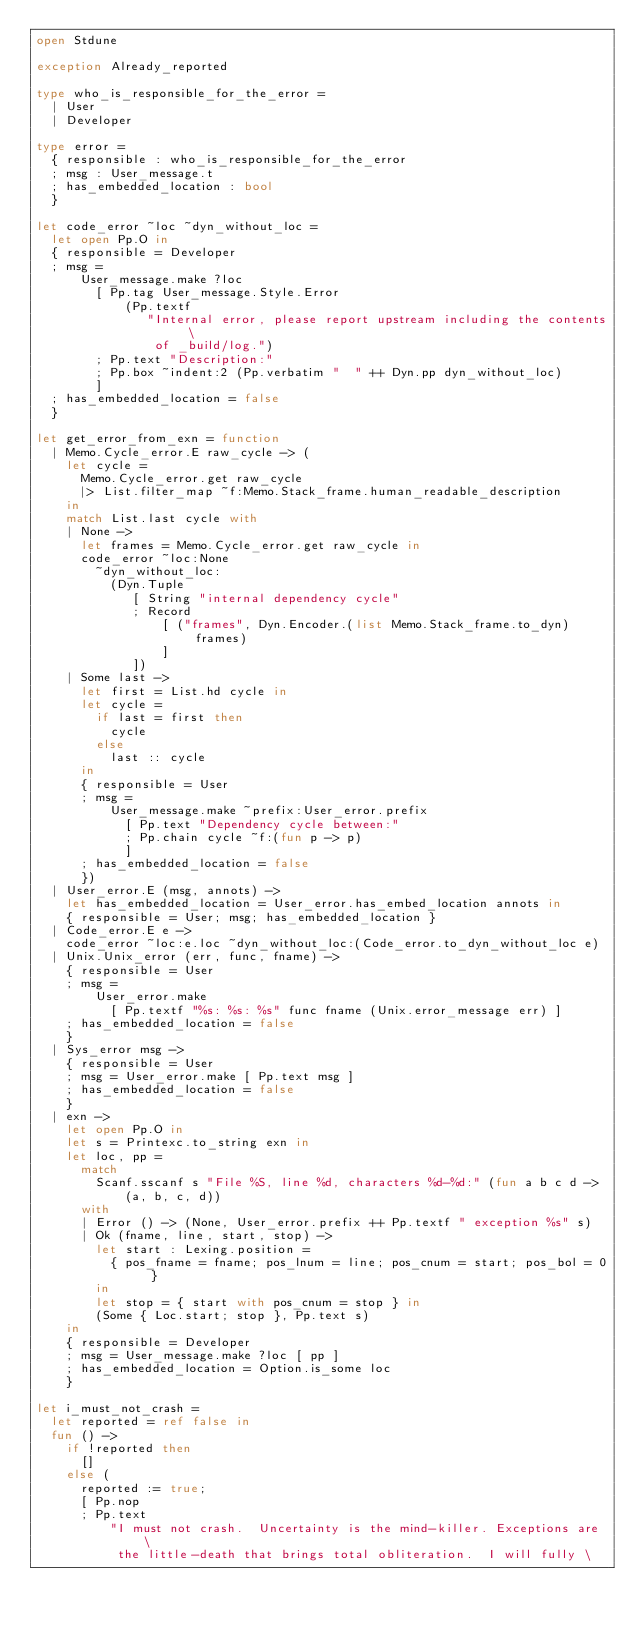<code> <loc_0><loc_0><loc_500><loc_500><_OCaml_>open Stdune

exception Already_reported

type who_is_responsible_for_the_error =
  | User
  | Developer

type error =
  { responsible : who_is_responsible_for_the_error
  ; msg : User_message.t
  ; has_embedded_location : bool
  }

let code_error ~loc ~dyn_without_loc =
  let open Pp.O in
  { responsible = Developer
  ; msg =
      User_message.make ?loc
        [ Pp.tag User_message.Style.Error
            (Pp.textf
               "Internal error, please report upstream including the contents \
                of _build/log.")
        ; Pp.text "Description:"
        ; Pp.box ~indent:2 (Pp.verbatim "  " ++ Dyn.pp dyn_without_loc)
        ]
  ; has_embedded_location = false
  }

let get_error_from_exn = function
  | Memo.Cycle_error.E raw_cycle -> (
    let cycle =
      Memo.Cycle_error.get raw_cycle
      |> List.filter_map ~f:Memo.Stack_frame.human_readable_description
    in
    match List.last cycle with
    | None ->
      let frames = Memo.Cycle_error.get raw_cycle in
      code_error ~loc:None
        ~dyn_without_loc:
          (Dyn.Tuple
             [ String "internal dependency cycle"
             ; Record
                 [ ("frames", Dyn.Encoder.(list Memo.Stack_frame.to_dyn) frames)
                 ]
             ])
    | Some last ->
      let first = List.hd cycle in
      let cycle =
        if last = first then
          cycle
        else
          last :: cycle
      in
      { responsible = User
      ; msg =
          User_message.make ~prefix:User_error.prefix
            [ Pp.text "Dependency cycle between:"
            ; Pp.chain cycle ~f:(fun p -> p)
            ]
      ; has_embedded_location = false
      })
  | User_error.E (msg, annots) ->
    let has_embedded_location = User_error.has_embed_location annots in
    { responsible = User; msg; has_embedded_location }
  | Code_error.E e ->
    code_error ~loc:e.loc ~dyn_without_loc:(Code_error.to_dyn_without_loc e)
  | Unix.Unix_error (err, func, fname) ->
    { responsible = User
    ; msg =
        User_error.make
          [ Pp.textf "%s: %s: %s" func fname (Unix.error_message err) ]
    ; has_embedded_location = false
    }
  | Sys_error msg ->
    { responsible = User
    ; msg = User_error.make [ Pp.text msg ]
    ; has_embedded_location = false
    }
  | exn ->
    let open Pp.O in
    let s = Printexc.to_string exn in
    let loc, pp =
      match
        Scanf.sscanf s "File %S, line %d, characters %d-%d:" (fun a b c d ->
            (a, b, c, d))
      with
      | Error () -> (None, User_error.prefix ++ Pp.textf " exception %s" s)
      | Ok (fname, line, start, stop) ->
        let start : Lexing.position =
          { pos_fname = fname; pos_lnum = line; pos_cnum = start; pos_bol = 0 }
        in
        let stop = { start with pos_cnum = stop } in
        (Some { Loc.start; stop }, Pp.text s)
    in
    { responsible = Developer
    ; msg = User_message.make ?loc [ pp ]
    ; has_embedded_location = Option.is_some loc
    }

let i_must_not_crash =
  let reported = ref false in
  fun () ->
    if !reported then
      []
    else (
      reported := true;
      [ Pp.nop
      ; Pp.text
          "I must not crash.  Uncertainty is the mind-killer. Exceptions are \
           the little-death that brings total obliteration.  I will fully \</code> 